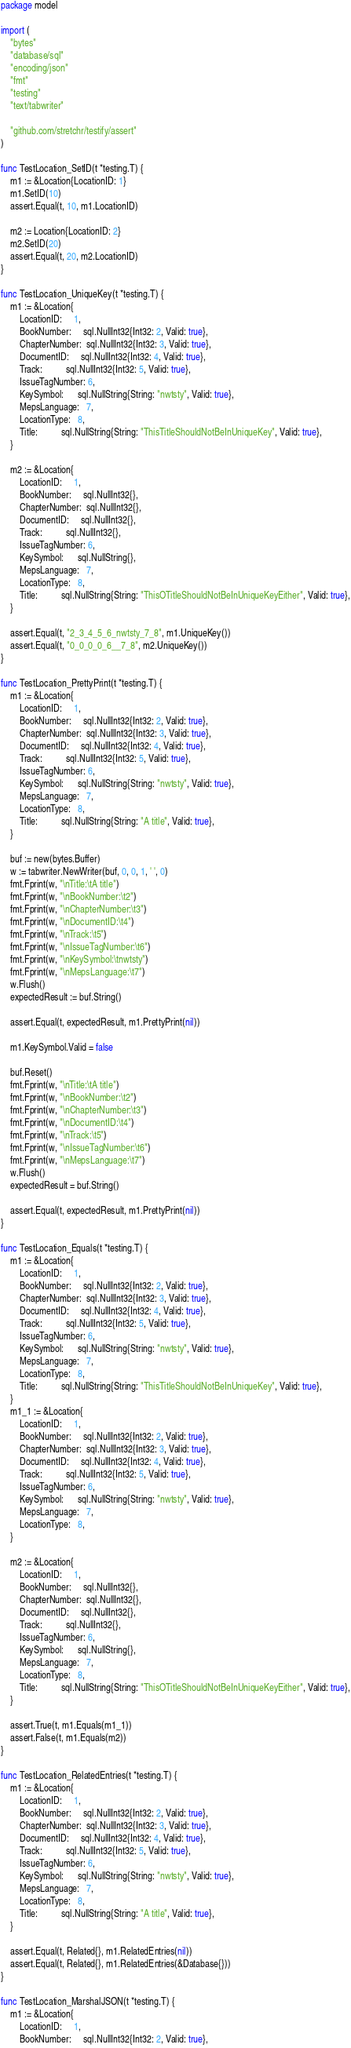<code> <loc_0><loc_0><loc_500><loc_500><_Go_>package model

import (
	"bytes"
	"database/sql"
	"encoding/json"
	"fmt"
	"testing"
	"text/tabwriter"

	"github.com/stretchr/testify/assert"
)

func TestLocation_SetID(t *testing.T) {
	m1 := &Location{LocationID: 1}
	m1.SetID(10)
	assert.Equal(t, 10, m1.LocationID)

	m2 := Location{LocationID: 2}
	m2.SetID(20)
	assert.Equal(t, 20, m2.LocationID)
}

func TestLocation_UniqueKey(t *testing.T) {
	m1 := &Location{
		LocationID:     1,
		BookNumber:     sql.NullInt32{Int32: 2, Valid: true},
		ChapterNumber:  sql.NullInt32{Int32: 3, Valid: true},
		DocumentID:     sql.NullInt32{Int32: 4, Valid: true},
		Track:          sql.NullInt32{Int32: 5, Valid: true},
		IssueTagNumber: 6,
		KeySymbol:      sql.NullString{String: "nwtsty", Valid: true},
		MepsLanguage:   7,
		LocationType:   8,
		Title:          sql.NullString{String: "ThisTitleShouldNotBeInUniqueKey", Valid: true},
	}

	m2 := &Location{
		LocationID:     1,
		BookNumber:     sql.NullInt32{},
		ChapterNumber:  sql.NullInt32{},
		DocumentID:     sql.NullInt32{},
		Track:          sql.NullInt32{},
		IssueTagNumber: 6,
		KeySymbol:      sql.NullString{},
		MepsLanguage:   7,
		LocationType:   8,
		Title:          sql.NullString{String: "ThisOTitleShouldNotBeInUniqueKeyEither", Valid: true},
	}

	assert.Equal(t, "2_3_4_5_6_nwtsty_7_8", m1.UniqueKey())
	assert.Equal(t, "0_0_0_0_6__7_8", m2.UniqueKey())
}

func TestLocation_PrettyPrint(t *testing.T) {
	m1 := &Location{
		LocationID:     1,
		BookNumber:     sql.NullInt32{Int32: 2, Valid: true},
		ChapterNumber:  sql.NullInt32{Int32: 3, Valid: true},
		DocumentID:     sql.NullInt32{Int32: 4, Valid: true},
		Track:          sql.NullInt32{Int32: 5, Valid: true},
		IssueTagNumber: 6,
		KeySymbol:      sql.NullString{String: "nwtsty", Valid: true},
		MepsLanguage:   7,
		LocationType:   8,
		Title:          sql.NullString{String: "A title", Valid: true},
	}

	buf := new(bytes.Buffer)
	w := tabwriter.NewWriter(buf, 0, 0, 1, ' ', 0)
	fmt.Fprint(w, "\nTitle:\tA title")
	fmt.Fprint(w, "\nBookNumber:\t2")
	fmt.Fprint(w, "\nChapterNumber:\t3")
	fmt.Fprint(w, "\nDocumentID:\t4")
	fmt.Fprint(w, "\nTrack:\t5")
	fmt.Fprint(w, "\nIssueTagNumber:\t6")
	fmt.Fprint(w, "\nKeySymbol:\tnwtsty")
	fmt.Fprint(w, "\nMepsLanguage:\t7")
	w.Flush()
	expectedResult := buf.String()

	assert.Equal(t, expectedResult, m1.PrettyPrint(nil))

	m1.KeySymbol.Valid = false

	buf.Reset()
	fmt.Fprint(w, "\nTitle:\tA title")
	fmt.Fprint(w, "\nBookNumber:\t2")
	fmt.Fprint(w, "\nChapterNumber:\t3")
	fmt.Fprint(w, "\nDocumentID:\t4")
	fmt.Fprint(w, "\nTrack:\t5")
	fmt.Fprint(w, "\nIssueTagNumber:\t6")
	fmt.Fprint(w, "\nMepsLanguage:\t7")
	w.Flush()
	expectedResult = buf.String()

	assert.Equal(t, expectedResult, m1.PrettyPrint(nil))
}

func TestLocation_Equals(t *testing.T) {
	m1 := &Location{
		LocationID:     1,
		BookNumber:     sql.NullInt32{Int32: 2, Valid: true},
		ChapterNumber:  sql.NullInt32{Int32: 3, Valid: true},
		DocumentID:     sql.NullInt32{Int32: 4, Valid: true},
		Track:          sql.NullInt32{Int32: 5, Valid: true},
		IssueTagNumber: 6,
		KeySymbol:      sql.NullString{String: "nwtsty", Valid: true},
		MepsLanguage:   7,
		LocationType:   8,
		Title:          sql.NullString{String: "ThisTitleShouldNotBeInUniqueKey", Valid: true},
	}
	m1_1 := &Location{
		LocationID:     1,
		BookNumber:     sql.NullInt32{Int32: 2, Valid: true},
		ChapterNumber:  sql.NullInt32{Int32: 3, Valid: true},
		DocumentID:     sql.NullInt32{Int32: 4, Valid: true},
		Track:          sql.NullInt32{Int32: 5, Valid: true},
		IssueTagNumber: 6,
		KeySymbol:      sql.NullString{String: "nwtsty", Valid: true},
		MepsLanguage:   7,
		LocationType:   8,
	}

	m2 := &Location{
		LocationID:     1,
		BookNumber:     sql.NullInt32{},
		ChapterNumber:  sql.NullInt32{},
		DocumentID:     sql.NullInt32{},
		Track:          sql.NullInt32{},
		IssueTagNumber: 6,
		KeySymbol:      sql.NullString{},
		MepsLanguage:   7,
		LocationType:   8,
		Title:          sql.NullString{String: "ThisOTitleShouldNotBeInUniqueKeyEither", Valid: true},
	}

	assert.True(t, m1.Equals(m1_1))
	assert.False(t, m1.Equals(m2))
}

func TestLocation_RelatedEntries(t *testing.T) {
	m1 := &Location{
		LocationID:     1,
		BookNumber:     sql.NullInt32{Int32: 2, Valid: true},
		ChapterNumber:  sql.NullInt32{Int32: 3, Valid: true},
		DocumentID:     sql.NullInt32{Int32: 4, Valid: true},
		Track:          sql.NullInt32{Int32: 5, Valid: true},
		IssueTagNumber: 6,
		KeySymbol:      sql.NullString{String: "nwtsty", Valid: true},
		MepsLanguage:   7,
		LocationType:   8,
		Title:          sql.NullString{String: "A title", Valid: true},
	}

	assert.Equal(t, Related{}, m1.RelatedEntries(nil))
	assert.Equal(t, Related{}, m1.RelatedEntries(&Database{}))
}

func TestLocation_MarshalJSON(t *testing.T) {
	m1 := &Location{
		LocationID:     1,
		BookNumber:     sql.NullInt32{Int32: 2, Valid: true},</code> 